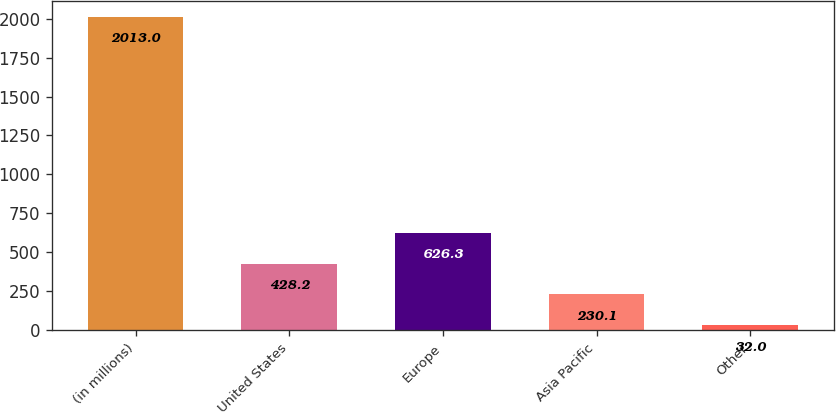Convert chart to OTSL. <chart><loc_0><loc_0><loc_500><loc_500><bar_chart><fcel>(in millions)<fcel>United States<fcel>Europe<fcel>Asia Pacific<fcel>Other<nl><fcel>2013<fcel>428.2<fcel>626.3<fcel>230.1<fcel>32<nl></chart> 